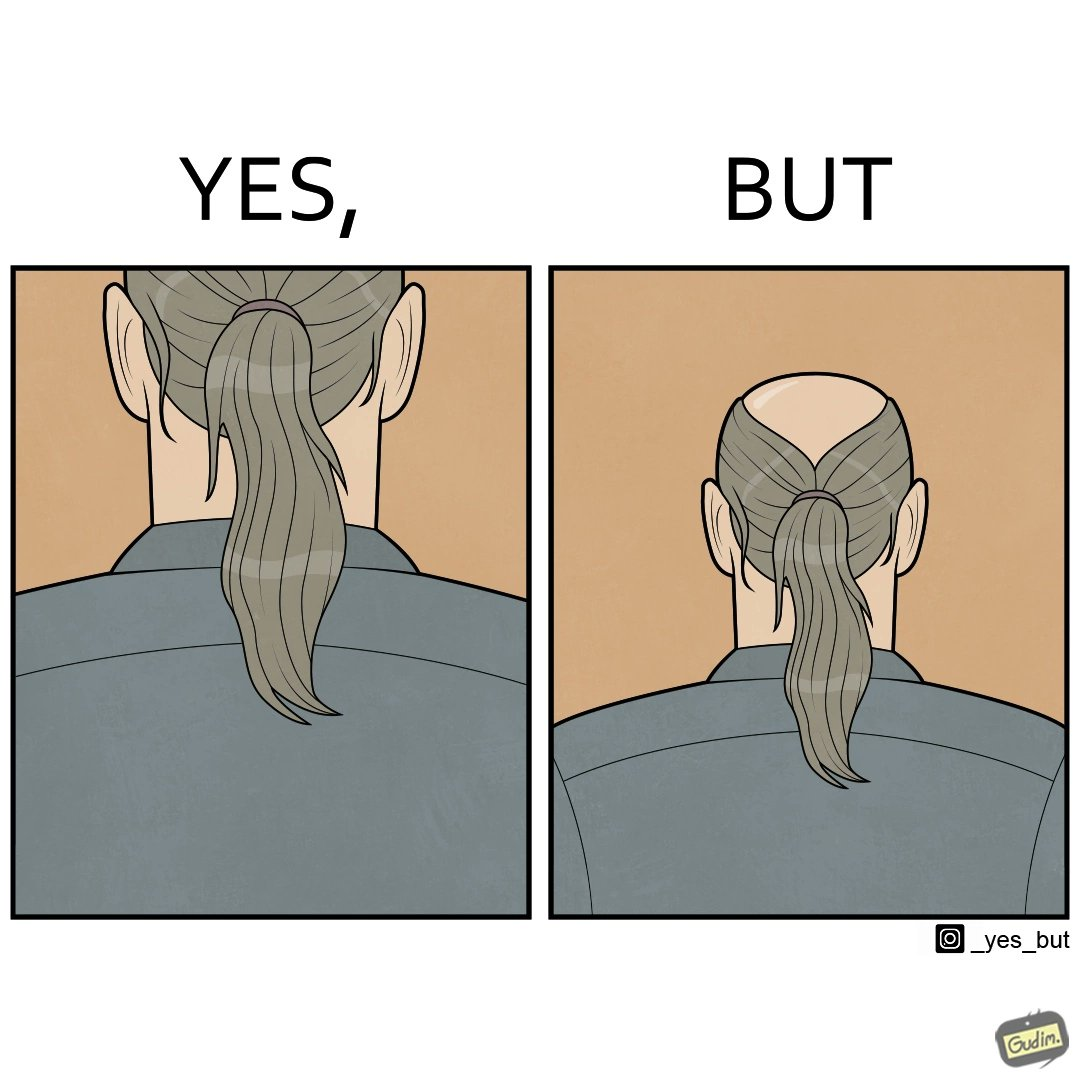What do you see in each half of this image? In the left part of the image: It is a ponytail In the right part of the image: It is a head with a ponytail on the bottom but with a bald patch on top 